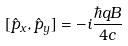<formula> <loc_0><loc_0><loc_500><loc_500>[ \hat { p } _ { x } , \hat { p } _ { y } ] = - i \frac { \hbar { q } B } { 4 c }</formula> 